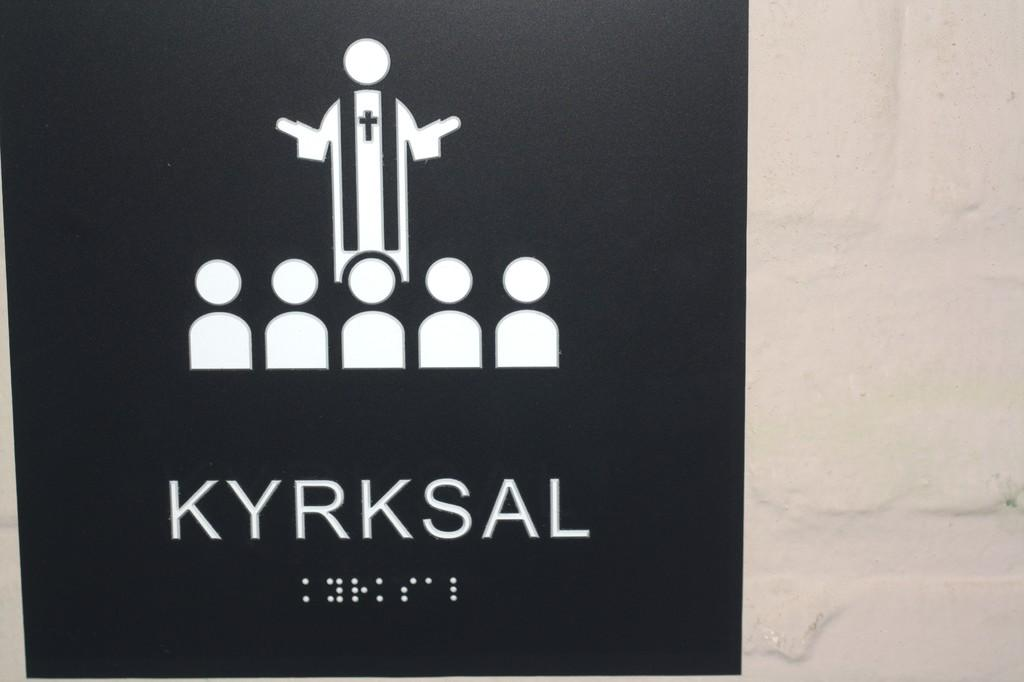<image>
Write a terse but informative summary of the picture. Black sign with white words that say "KYRKSAL". 